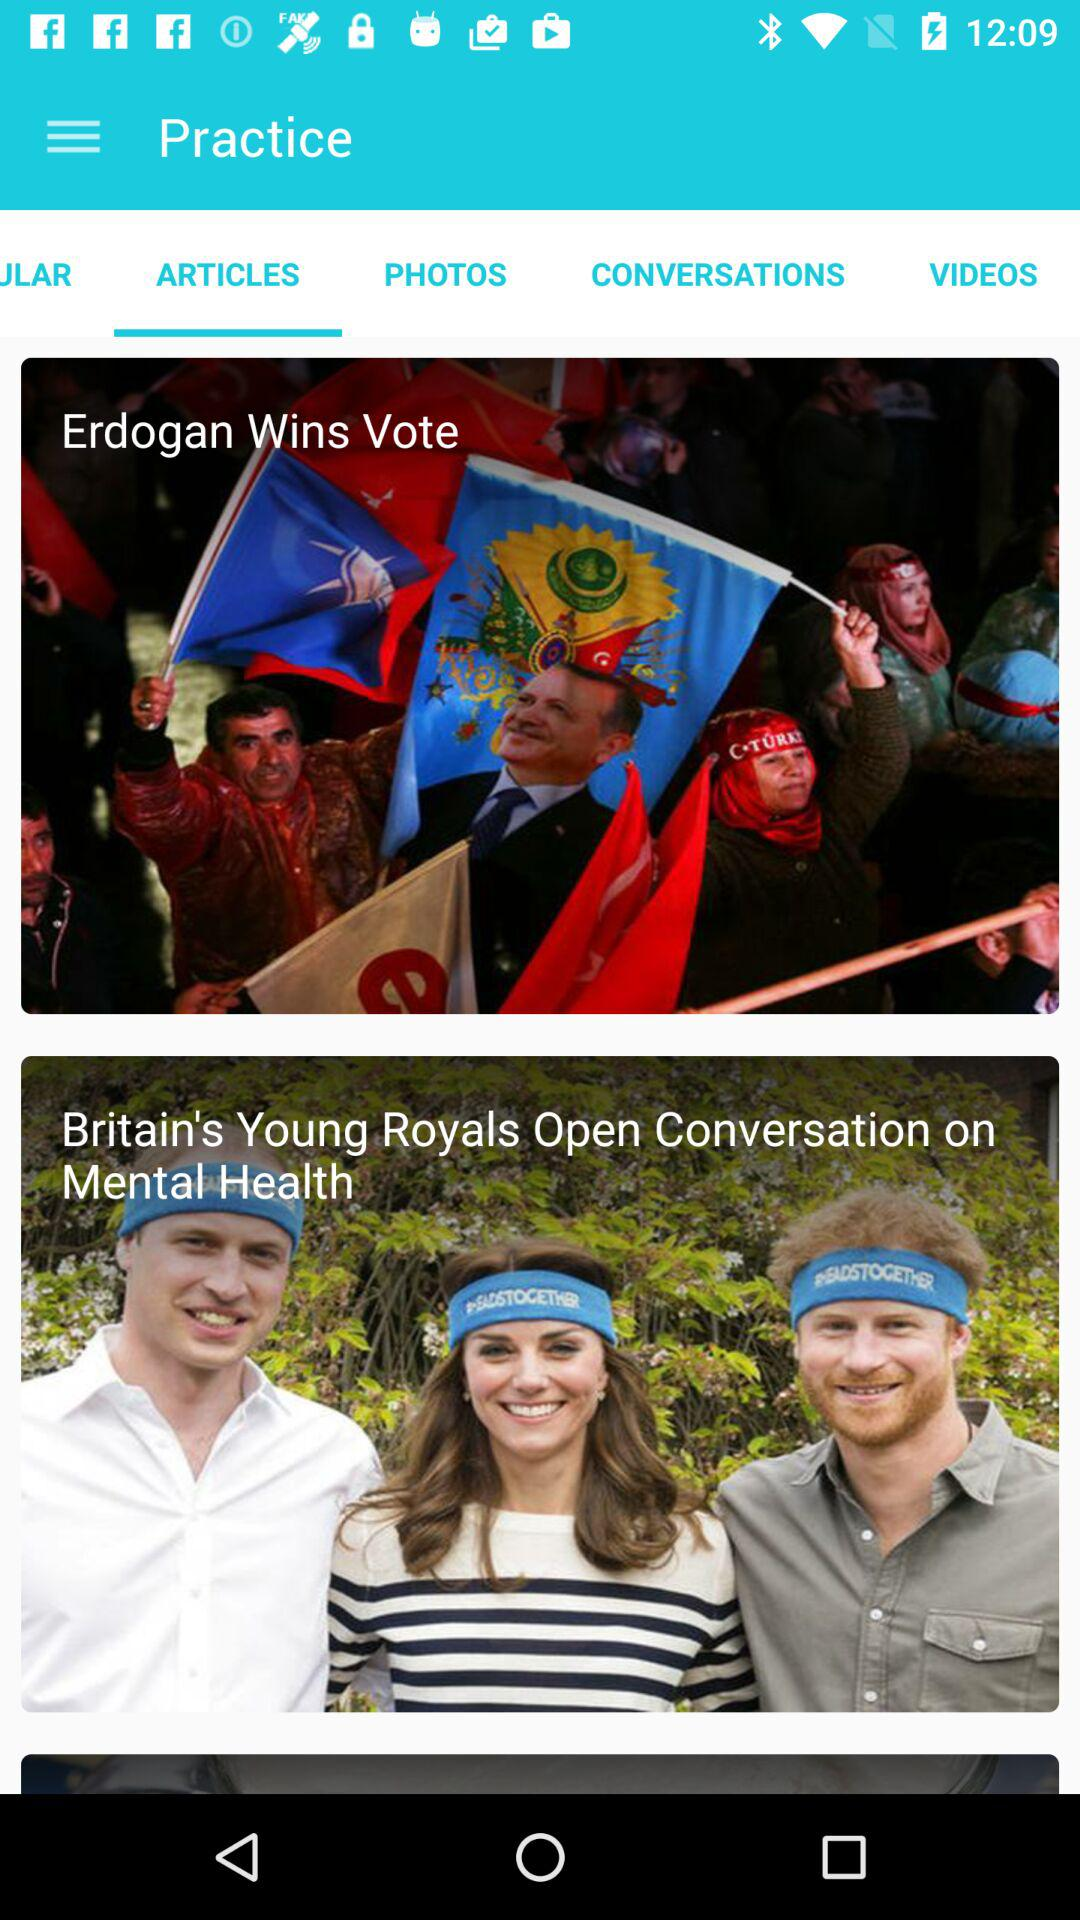Which tab has been selected? The tab that has been selected is "ARTICLES". 